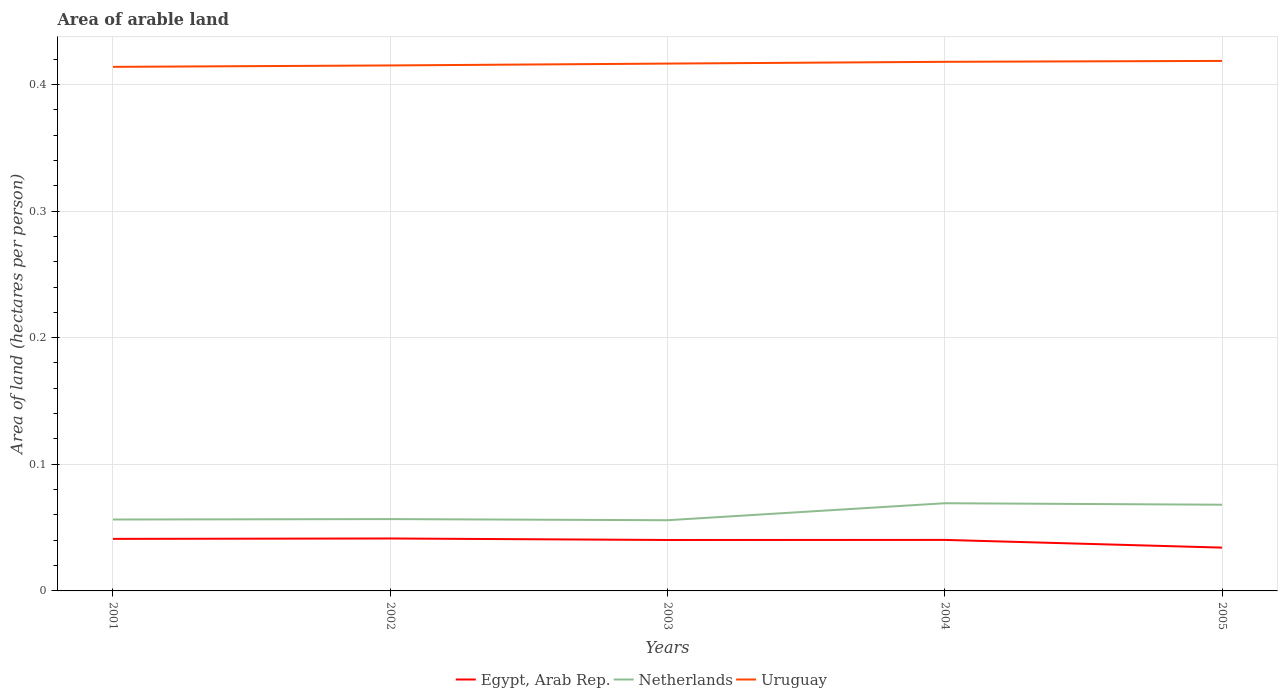Does the line corresponding to Netherlands intersect with the line corresponding to Egypt, Arab Rep.?
Offer a terse response. No. Across all years, what is the maximum total arable land in Netherlands?
Provide a succinct answer. 0.06. What is the total total arable land in Netherlands in the graph?
Give a very brief answer. 0. What is the difference between the highest and the second highest total arable land in Uruguay?
Your response must be concise. 0. What is the difference between the highest and the lowest total arable land in Netherlands?
Offer a very short reply. 2. How many years are there in the graph?
Provide a succinct answer. 5. What is the difference between two consecutive major ticks on the Y-axis?
Provide a short and direct response. 0.1. Are the values on the major ticks of Y-axis written in scientific E-notation?
Provide a short and direct response. No. Does the graph contain any zero values?
Your response must be concise. No. Where does the legend appear in the graph?
Your response must be concise. Bottom center. How are the legend labels stacked?
Provide a short and direct response. Horizontal. What is the title of the graph?
Offer a terse response. Area of arable land. What is the label or title of the Y-axis?
Offer a terse response. Area of land (hectares per person). What is the Area of land (hectares per person) in Egypt, Arab Rep. in 2001?
Your response must be concise. 0.04. What is the Area of land (hectares per person) of Netherlands in 2001?
Provide a succinct answer. 0.06. What is the Area of land (hectares per person) in Uruguay in 2001?
Your response must be concise. 0.41. What is the Area of land (hectares per person) of Egypt, Arab Rep. in 2002?
Provide a succinct answer. 0.04. What is the Area of land (hectares per person) in Netherlands in 2002?
Your answer should be very brief. 0.06. What is the Area of land (hectares per person) in Uruguay in 2002?
Your answer should be very brief. 0.41. What is the Area of land (hectares per person) in Egypt, Arab Rep. in 2003?
Offer a terse response. 0.04. What is the Area of land (hectares per person) of Netherlands in 2003?
Your response must be concise. 0.06. What is the Area of land (hectares per person) of Uruguay in 2003?
Your answer should be very brief. 0.42. What is the Area of land (hectares per person) in Egypt, Arab Rep. in 2004?
Your answer should be compact. 0.04. What is the Area of land (hectares per person) in Netherlands in 2004?
Ensure brevity in your answer.  0.07. What is the Area of land (hectares per person) of Uruguay in 2004?
Keep it short and to the point. 0.42. What is the Area of land (hectares per person) in Egypt, Arab Rep. in 2005?
Keep it short and to the point. 0.03. What is the Area of land (hectares per person) of Netherlands in 2005?
Your answer should be compact. 0.07. What is the Area of land (hectares per person) of Uruguay in 2005?
Offer a terse response. 0.42. Across all years, what is the maximum Area of land (hectares per person) in Egypt, Arab Rep.?
Make the answer very short. 0.04. Across all years, what is the maximum Area of land (hectares per person) of Netherlands?
Ensure brevity in your answer.  0.07. Across all years, what is the maximum Area of land (hectares per person) of Uruguay?
Give a very brief answer. 0.42. Across all years, what is the minimum Area of land (hectares per person) in Egypt, Arab Rep.?
Offer a terse response. 0.03. Across all years, what is the minimum Area of land (hectares per person) in Netherlands?
Keep it short and to the point. 0.06. Across all years, what is the minimum Area of land (hectares per person) in Uruguay?
Give a very brief answer. 0.41. What is the total Area of land (hectares per person) in Egypt, Arab Rep. in the graph?
Your response must be concise. 0.2. What is the total Area of land (hectares per person) of Netherlands in the graph?
Provide a succinct answer. 0.31. What is the total Area of land (hectares per person) of Uruguay in the graph?
Keep it short and to the point. 2.08. What is the difference between the Area of land (hectares per person) in Egypt, Arab Rep. in 2001 and that in 2002?
Make the answer very short. -0. What is the difference between the Area of land (hectares per person) of Netherlands in 2001 and that in 2002?
Keep it short and to the point. -0. What is the difference between the Area of land (hectares per person) of Uruguay in 2001 and that in 2002?
Offer a very short reply. -0. What is the difference between the Area of land (hectares per person) of Egypt, Arab Rep. in 2001 and that in 2003?
Provide a succinct answer. 0. What is the difference between the Area of land (hectares per person) of Netherlands in 2001 and that in 2003?
Keep it short and to the point. 0. What is the difference between the Area of land (hectares per person) in Uruguay in 2001 and that in 2003?
Your answer should be compact. -0. What is the difference between the Area of land (hectares per person) in Egypt, Arab Rep. in 2001 and that in 2004?
Offer a terse response. 0. What is the difference between the Area of land (hectares per person) in Netherlands in 2001 and that in 2004?
Offer a very short reply. -0.01. What is the difference between the Area of land (hectares per person) of Uruguay in 2001 and that in 2004?
Provide a succinct answer. -0. What is the difference between the Area of land (hectares per person) of Egypt, Arab Rep. in 2001 and that in 2005?
Offer a very short reply. 0.01. What is the difference between the Area of land (hectares per person) of Netherlands in 2001 and that in 2005?
Give a very brief answer. -0.01. What is the difference between the Area of land (hectares per person) in Uruguay in 2001 and that in 2005?
Keep it short and to the point. -0. What is the difference between the Area of land (hectares per person) in Egypt, Arab Rep. in 2002 and that in 2003?
Provide a succinct answer. 0. What is the difference between the Area of land (hectares per person) in Netherlands in 2002 and that in 2003?
Provide a short and direct response. 0. What is the difference between the Area of land (hectares per person) in Uruguay in 2002 and that in 2003?
Your response must be concise. -0. What is the difference between the Area of land (hectares per person) in Egypt, Arab Rep. in 2002 and that in 2004?
Give a very brief answer. 0. What is the difference between the Area of land (hectares per person) of Netherlands in 2002 and that in 2004?
Your response must be concise. -0.01. What is the difference between the Area of land (hectares per person) in Uruguay in 2002 and that in 2004?
Provide a succinct answer. -0. What is the difference between the Area of land (hectares per person) in Egypt, Arab Rep. in 2002 and that in 2005?
Ensure brevity in your answer.  0.01. What is the difference between the Area of land (hectares per person) of Netherlands in 2002 and that in 2005?
Keep it short and to the point. -0.01. What is the difference between the Area of land (hectares per person) of Uruguay in 2002 and that in 2005?
Keep it short and to the point. -0. What is the difference between the Area of land (hectares per person) of Egypt, Arab Rep. in 2003 and that in 2004?
Offer a terse response. -0. What is the difference between the Area of land (hectares per person) in Netherlands in 2003 and that in 2004?
Provide a short and direct response. -0.01. What is the difference between the Area of land (hectares per person) of Uruguay in 2003 and that in 2004?
Offer a very short reply. -0. What is the difference between the Area of land (hectares per person) in Egypt, Arab Rep. in 2003 and that in 2005?
Make the answer very short. 0.01. What is the difference between the Area of land (hectares per person) in Netherlands in 2003 and that in 2005?
Keep it short and to the point. -0.01. What is the difference between the Area of land (hectares per person) of Uruguay in 2003 and that in 2005?
Your answer should be compact. -0. What is the difference between the Area of land (hectares per person) in Egypt, Arab Rep. in 2004 and that in 2005?
Your response must be concise. 0.01. What is the difference between the Area of land (hectares per person) of Netherlands in 2004 and that in 2005?
Offer a terse response. 0. What is the difference between the Area of land (hectares per person) in Uruguay in 2004 and that in 2005?
Provide a succinct answer. -0. What is the difference between the Area of land (hectares per person) of Egypt, Arab Rep. in 2001 and the Area of land (hectares per person) of Netherlands in 2002?
Your answer should be compact. -0.02. What is the difference between the Area of land (hectares per person) of Egypt, Arab Rep. in 2001 and the Area of land (hectares per person) of Uruguay in 2002?
Keep it short and to the point. -0.37. What is the difference between the Area of land (hectares per person) in Netherlands in 2001 and the Area of land (hectares per person) in Uruguay in 2002?
Keep it short and to the point. -0.36. What is the difference between the Area of land (hectares per person) of Egypt, Arab Rep. in 2001 and the Area of land (hectares per person) of Netherlands in 2003?
Your response must be concise. -0.01. What is the difference between the Area of land (hectares per person) of Egypt, Arab Rep. in 2001 and the Area of land (hectares per person) of Uruguay in 2003?
Offer a very short reply. -0.38. What is the difference between the Area of land (hectares per person) of Netherlands in 2001 and the Area of land (hectares per person) of Uruguay in 2003?
Give a very brief answer. -0.36. What is the difference between the Area of land (hectares per person) of Egypt, Arab Rep. in 2001 and the Area of land (hectares per person) of Netherlands in 2004?
Offer a very short reply. -0.03. What is the difference between the Area of land (hectares per person) of Egypt, Arab Rep. in 2001 and the Area of land (hectares per person) of Uruguay in 2004?
Give a very brief answer. -0.38. What is the difference between the Area of land (hectares per person) of Netherlands in 2001 and the Area of land (hectares per person) of Uruguay in 2004?
Ensure brevity in your answer.  -0.36. What is the difference between the Area of land (hectares per person) in Egypt, Arab Rep. in 2001 and the Area of land (hectares per person) in Netherlands in 2005?
Keep it short and to the point. -0.03. What is the difference between the Area of land (hectares per person) of Egypt, Arab Rep. in 2001 and the Area of land (hectares per person) of Uruguay in 2005?
Your answer should be compact. -0.38. What is the difference between the Area of land (hectares per person) of Netherlands in 2001 and the Area of land (hectares per person) of Uruguay in 2005?
Ensure brevity in your answer.  -0.36. What is the difference between the Area of land (hectares per person) in Egypt, Arab Rep. in 2002 and the Area of land (hectares per person) in Netherlands in 2003?
Ensure brevity in your answer.  -0.01. What is the difference between the Area of land (hectares per person) in Egypt, Arab Rep. in 2002 and the Area of land (hectares per person) in Uruguay in 2003?
Ensure brevity in your answer.  -0.38. What is the difference between the Area of land (hectares per person) in Netherlands in 2002 and the Area of land (hectares per person) in Uruguay in 2003?
Provide a short and direct response. -0.36. What is the difference between the Area of land (hectares per person) in Egypt, Arab Rep. in 2002 and the Area of land (hectares per person) in Netherlands in 2004?
Make the answer very short. -0.03. What is the difference between the Area of land (hectares per person) in Egypt, Arab Rep. in 2002 and the Area of land (hectares per person) in Uruguay in 2004?
Provide a short and direct response. -0.38. What is the difference between the Area of land (hectares per person) in Netherlands in 2002 and the Area of land (hectares per person) in Uruguay in 2004?
Provide a succinct answer. -0.36. What is the difference between the Area of land (hectares per person) in Egypt, Arab Rep. in 2002 and the Area of land (hectares per person) in Netherlands in 2005?
Give a very brief answer. -0.03. What is the difference between the Area of land (hectares per person) of Egypt, Arab Rep. in 2002 and the Area of land (hectares per person) of Uruguay in 2005?
Offer a terse response. -0.38. What is the difference between the Area of land (hectares per person) of Netherlands in 2002 and the Area of land (hectares per person) of Uruguay in 2005?
Offer a very short reply. -0.36. What is the difference between the Area of land (hectares per person) in Egypt, Arab Rep. in 2003 and the Area of land (hectares per person) in Netherlands in 2004?
Provide a short and direct response. -0.03. What is the difference between the Area of land (hectares per person) of Egypt, Arab Rep. in 2003 and the Area of land (hectares per person) of Uruguay in 2004?
Provide a short and direct response. -0.38. What is the difference between the Area of land (hectares per person) in Netherlands in 2003 and the Area of land (hectares per person) in Uruguay in 2004?
Keep it short and to the point. -0.36. What is the difference between the Area of land (hectares per person) in Egypt, Arab Rep. in 2003 and the Area of land (hectares per person) in Netherlands in 2005?
Keep it short and to the point. -0.03. What is the difference between the Area of land (hectares per person) of Egypt, Arab Rep. in 2003 and the Area of land (hectares per person) of Uruguay in 2005?
Ensure brevity in your answer.  -0.38. What is the difference between the Area of land (hectares per person) of Netherlands in 2003 and the Area of land (hectares per person) of Uruguay in 2005?
Your answer should be very brief. -0.36. What is the difference between the Area of land (hectares per person) of Egypt, Arab Rep. in 2004 and the Area of land (hectares per person) of Netherlands in 2005?
Your answer should be compact. -0.03. What is the difference between the Area of land (hectares per person) of Egypt, Arab Rep. in 2004 and the Area of land (hectares per person) of Uruguay in 2005?
Offer a very short reply. -0.38. What is the difference between the Area of land (hectares per person) in Netherlands in 2004 and the Area of land (hectares per person) in Uruguay in 2005?
Your answer should be very brief. -0.35. What is the average Area of land (hectares per person) in Egypt, Arab Rep. per year?
Offer a terse response. 0.04. What is the average Area of land (hectares per person) of Netherlands per year?
Offer a terse response. 0.06. What is the average Area of land (hectares per person) of Uruguay per year?
Your response must be concise. 0.42. In the year 2001, what is the difference between the Area of land (hectares per person) of Egypt, Arab Rep. and Area of land (hectares per person) of Netherlands?
Your answer should be compact. -0.02. In the year 2001, what is the difference between the Area of land (hectares per person) in Egypt, Arab Rep. and Area of land (hectares per person) in Uruguay?
Your answer should be very brief. -0.37. In the year 2001, what is the difference between the Area of land (hectares per person) in Netherlands and Area of land (hectares per person) in Uruguay?
Your answer should be very brief. -0.36. In the year 2002, what is the difference between the Area of land (hectares per person) in Egypt, Arab Rep. and Area of land (hectares per person) in Netherlands?
Give a very brief answer. -0.02. In the year 2002, what is the difference between the Area of land (hectares per person) of Egypt, Arab Rep. and Area of land (hectares per person) of Uruguay?
Keep it short and to the point. -0.37. In the year 2002, what is the difference between the Area of land (hectares per person) in Netherlands and Area of land (hectares per person) in Uruguay?
Ensure brevity in your answer.  -0.36. In the year 2003, what is the difference between the Area of land (hectares per person) in Egypt, Arab Rep. and Area of land (hectares per person) in Netherlands?
Your response must be concise. -0.02. In the year 2003, what is the difference between the Area of land (hectares per person) of Egypt, Arab Rep. and Area of land (hectares per person) of Uruguay?
Your answer should be compact. -0.38. In the year 2003, what is the difference between the Area of land (hectares per person) in Netherlands and Area of land (hectares per person) in Uruguay?
Your answer should be very brief. -0.36. In the year 2004, what is the difference between the Area of land (hectares per person) in Egypt, Arab Rep. and Area of land (hectares per person) in Netherlands?
Your response must be concise. -0.03. In the year 2004, what is the difference between the Area of land (hectares per person) in Egypt, Arab Rep. and Area of land (hectares per person) in Uruguay?
Provide a succinct answer. -0.38. In the year 2004, what is the difference between the Area of land (hectares per person) of Netherlands and Area of land (hectares per person) of Uruguay?
Offer a terse response. -0.35. In the year 2005, what is the difference between the Area of land (hectares per person) of Egypt, Arab Rep. and Area of land (hectares per person) of Netherlands?
Provide a short and direct response. -0.03. In the year 2005, what is the difference between the Area of land (hectares per person) in Egypt, Arab Rep. and Area of land (hectares per person) in Uruguay?
Offer a very short reply. -0.38. In the year 2005, what is the difference between the Area of land (hectares per person) in Netherlands and Area of land (hectares per person) in Uruguay?
Your answer should be very brief. -0.35. What is the ratio of the Area of land (hectares per person) of Netherlands in 2001 to that in 2002?
Your response must be concise. 0.99. What is the ratio of the Area of land (hectares per person) in Uruguay in 2001 to that in 2003?
Your answer should be very brief. 0.99. What is the ratio of the Area of land (hectares per person) in Egypt, Arab Rep. in 2001 to that in 2004?
Offer a very short reply. 1.02. What is the ratio of the Area of land (hectares per person) in Netherlands in 2001 to that in 2004?
Ensure brevity in your answer.  0.81. What is the ratio of the Area of land (hectares per person) of Egypt, Arab Rep. in 2001 to that in 2005?
Make the answer very short. 1.2. What is the ratio of the Area of land (hectares per person) in Netherlands in 2001 to that in 2005?
Ensure brevity in your answer.  0.83. What is the ratio of the Area of land (hectares per person) in Egypt, Arab Rep. in 2002 to that in 2003?
Offer a very short reply. 1.03. What is the ratio of the Area of land (hectares per person) in Netherlands in 2002 to that in 2003?
Make the answer very short. 1.02. What is the ratio of the Area of land (hectares per person) of Egypt, Arab Rep. in 2002 to that in 2004?
Provide a short and direct response. 1.03. What is the ratio of the Area of land (hectares per person) in Netherlands in 2002 to that in 2004?
Keep it short and to the point. 0.82. What is the ratio of the Area of land (hectares per person) of Uruguay in 2002 to that in 2004?
Provide a succinct answer. 0.99. What is the ratio of the Area of land (hectares per person) of Egypt, Arab Rep. in 2002 to that in 2005?
Keep it short and to the point. 1.21. What is the ratio of the Area of land (hectares per person) of Netherlands in 2002 to that in 2005?
Your answer should be compact. 0.83. What is the ratio of the Area of land (hectares per person) of Uruguay in 2002 to that in 2005?
Offer a very short reply. 0.99. What is the ratio of the Area of land (hectares per person) of Egypt, Arab Rep. in 2003 to that in 2004?
Offer a terse response. 1. What is the ratio of the Area of land (hectares per person) of Netherlands in 2003 to that in 2004?
Offer a terse response. 0.81. What is the ratio of the Area of land (hectares per person) in Egypt, Arab Rep. in 2003 to that in 2005?
Keep it short and to the point. 1.18. What is the ratio of the Area of land (hectares per person) in Netherlands in 2003 to that in 2005?
Your response must be concise. 0.82. What is the ratio of the Area of land (hectares per person) of Egypt, Arab Rep. in 2004 to that in 2005?
Provide a succinct answer. 1.18. What is the ratio of the Area of land (hectares per person) of Netherlands in 2004 to that in 2005?
Provide a succinct answer. 1.02. What is the ratio of the Area of land (hectares per person) in Uruguay in 2004 to that in 2005?
Make the answer very short. 1. What is the difference between the highest and the second highest Area of land (hectares per person) in Egypt, Arab Rep.?
Keep it short and to the point. 0. What is the difference between the highest and the second highest Area of land (hectares per person) of Netherlands?
Offer a very short reply. 0. What is the difference between the highest and the second highest Area of land (hectares per person) of Uruguay?
Keep it short and to the point. 0. What is the difference between the highest and the lowest Area of land (hectares per person) of Egypt, Arab Rep.?
Keep it short and to the point. 0.01. What is the difference between the highest and the lowest Area of land (hectares per person) of Netherlands?
Offer a very short reply. 0.01. What is the difference between the highest and the lowest Area of land (hectares per person) of Uruguay?
Provide a succinct answer. 0. 